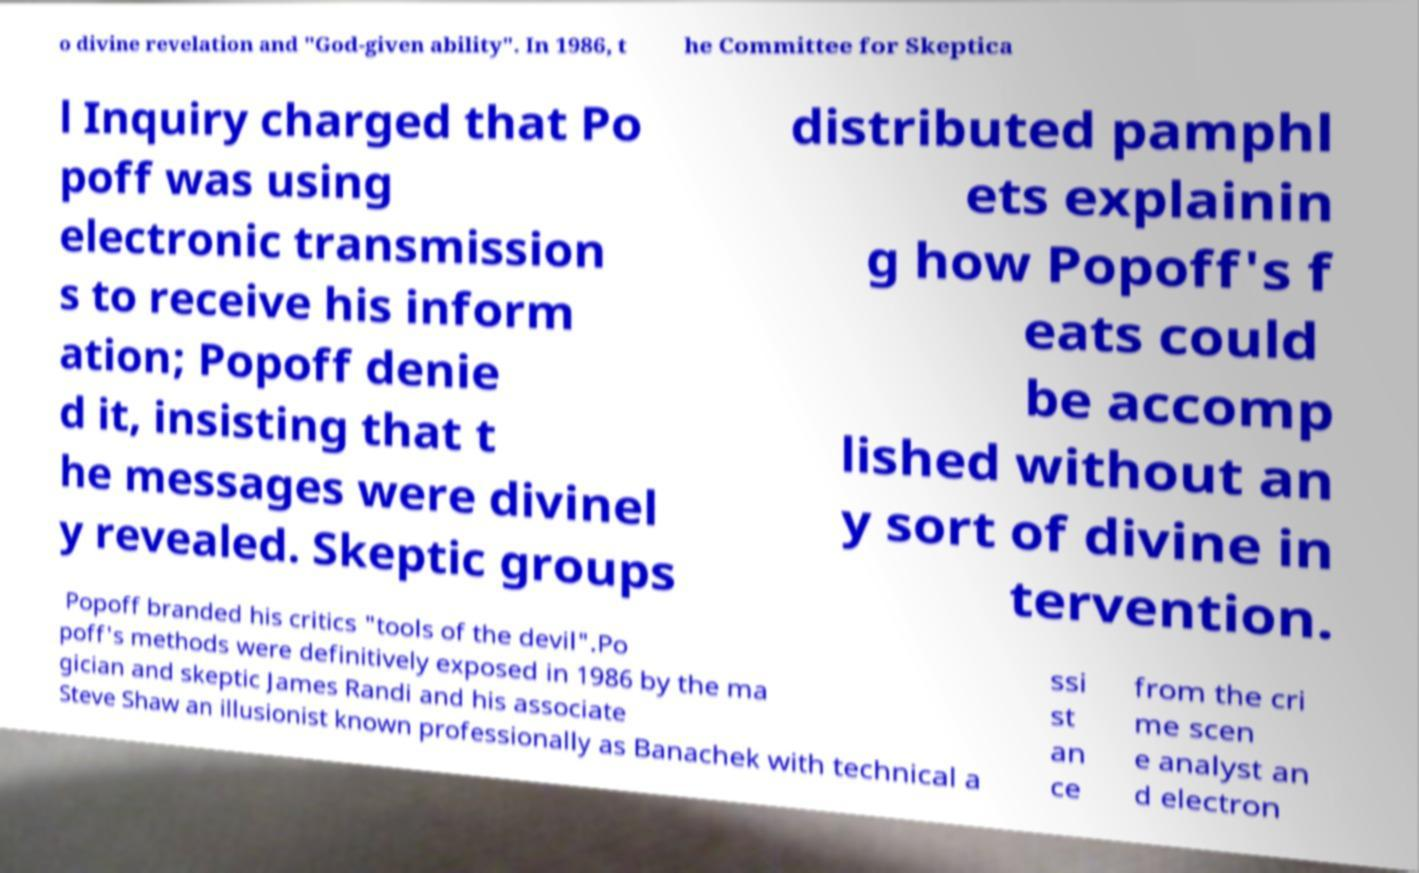I need the written content from this picture converted into text. Can you do that? o divine revelation and "God-given ability". In 1986, t he Committee for Skeptica l Inquiry charged that Po poff was using electronic transmission s to receive his inform ation; Popoff denie d it, insisting that t he messages were divinel y revealed. Skeptic groups distributed pamphl ets explainin g how Popoff's f eats could be accomp lished without an y sort of divine in tervention. Popoff branded his critics "tools of the devil".Po poff's methods were definitively exposed in 1986 by the ma gician and skeptic James Randi and his associate Steve Shaw an illusionist known professionally as Banachek with technical a ssi st an ce from the cri me scen e analyst an d electron 